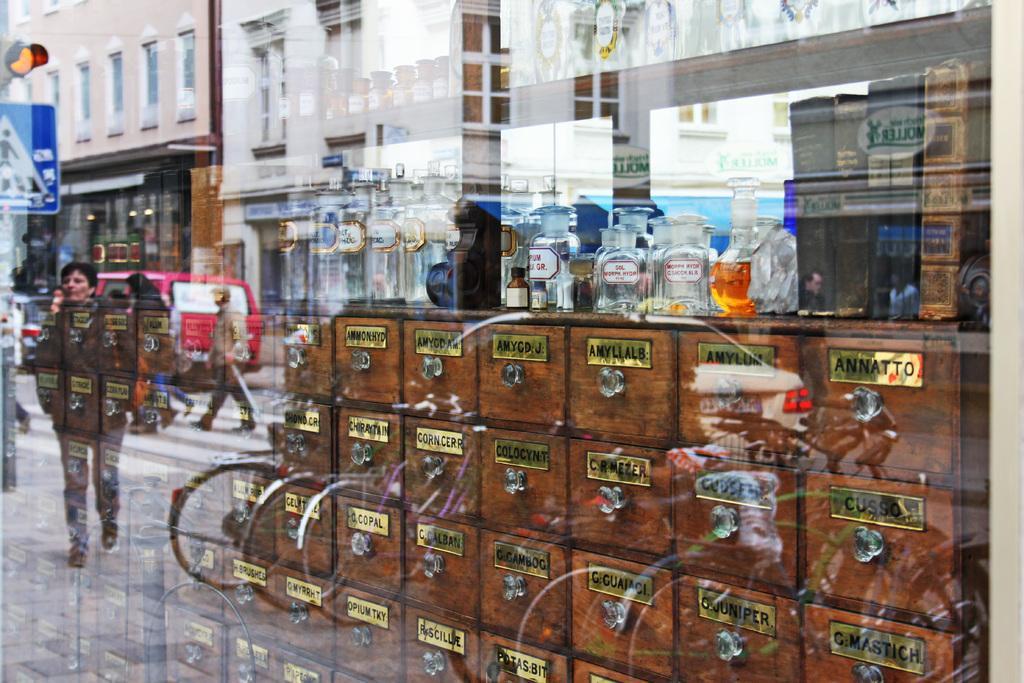Please provide a concise description of this image. In this picture I can see there is a glass window and I can see there is a reflection of bicycles, people walking on the walkway, there are poles with boards, traffic lights and there are few vehicles moving on the road. Behind the glass there are few bottles placed on the wooden drawers. 